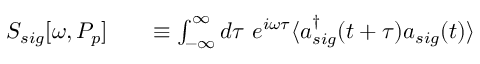<formula> <loc_0><loc_0><loc_500><loc_500>\begin{array} { r l r } { S _ { s i g } [ \omega , P _ { p } ] } & { \equiv \int _ { - \infty } ^ { \infty } d \tau \ e ^ { i \omega \tau } \langle a _ { s i g } ^ { \dag } ( t + \tau ) a _ { s i g } ( t ) \rangle } \end{array}</formula> 